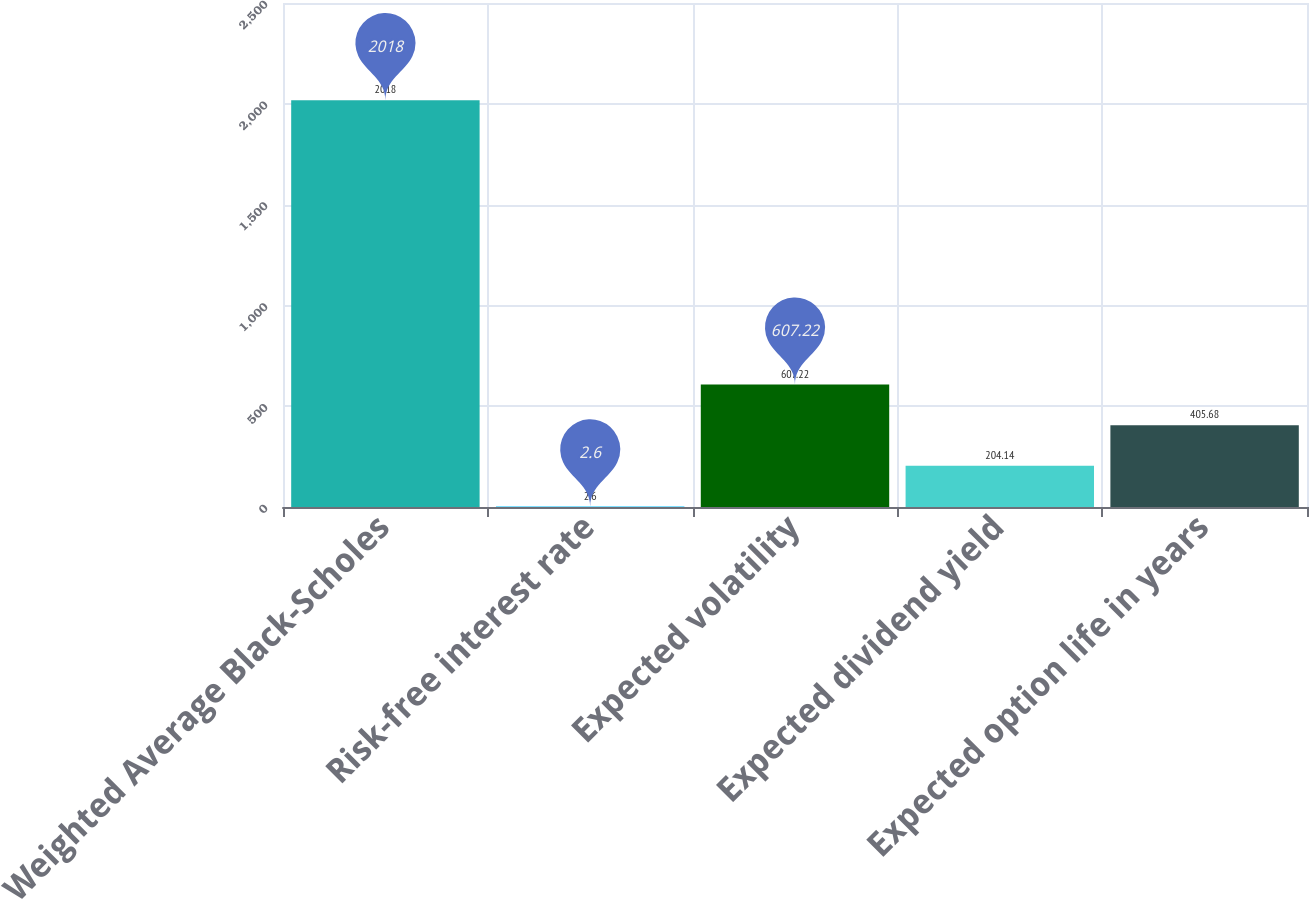<chart> <loc_0><loc_0><loc_500><loc_500><bar_chart><fcel>Weighted Average Black-Scholes<fcel>Risk-free interest rate<fcel>Expected volatility<fcel>Expected dividend yield<fcel>Expected option life in years<nl><fcel>2018<fcel>2.6<fcel>607.22<fcel>204.14<fcel>405.68<nl></chart> 